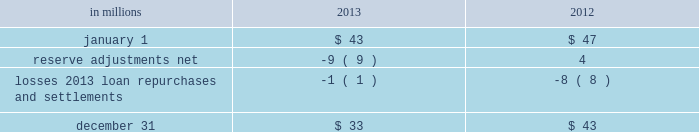Recourse and repurchase obligations as discussed in note 3 loan sale and servicing activities and variable interest entities , pnc has sold commercial mortgage , residential mortgage and home equity loans directly or indirectly through securitization and loan sale transactions in which we have continuing involvement .
One form of continuing involvement includes certain recourse and loan repurchase obligations associated with the transferred assets .
Commercial mortgage loan recourse obligations we originate , close and service certain multi-family commercial mortgage loans which are sold to fnma under fnma 2019s delegated underwriting and servicing ( dus ) program .
We participated in a similar program with the fhlmc .
Under these programs , we generally assume up to a one-third pari passu risk of loss on unpaid principal balances through a loss share arrangement .
At december 31 , 2013 and december 31 , 2012 , the unpaid principal balance outstanding of loans sold as a participant in these programs was $ 11.7 billion and $ 12.8 billion , respectively .
The potential maximum exposure under the loss share arrangements was $ 3.6 billion at december 31 , 2013 and $ 3.9 billion at december 31 , 2012 .
We maintain a reserve for estimated losses based upon our exposure .
The reserve for losses under these programs totaled $ 33 million and $ 43 million as of december 31 , 2013 and december 31 , 2012 , respectively , and is included in other liabilities on our consolidated balance sheet .
If payment is required under these programs , we would not have a contractual interest in the collateral underlying the mortgage loans on which losses occurred , although the value of the collateral is taken into account in determining our share of such losses .
Our exposure and activity associated with these recourse obligations are reported in the corporate & institutional banking segment .
Table 152 : analysis of commercial mortgage recourse obligations .
Residential mortgage loan and home equity repurchase obligations while residential mortgage loans are sold on a non-recourse basis , we assume certain loan repurchase obligations associated with mortgage loans we have sold to investors .
These loan repurchase obligations primarily relate to situations where pnc is alleged to have breached certain origination covenants and representations and warranties made to purchasers of the loans in the respective purchase and sale agreements .
For additional information on loan sales see note 3 loan sale and servicing activities and variable interest entities .
Our historical exposure and activity associated with agency securitization repurchase obligations has primarily been related to transactions with fnma and fhlmc , as indemnification and repurchase losses associated with fha and va-insured and uninsured loans pooled in gnma securitizations historically have been minimal .
Repurchase obligation activity associated with residential mortgages is reported in the residential mortgage banking segment .
In the fourth quarter of 2013 , pnc reached agreements with both fnma and fhlmc to resolve their repurchase claims with respect to loans sold between 2000 and 2008 .
Pnc paid a total of $ 191 million related to these settlements .
Pnc 2019s repurchase obligations also include certain brokered home equity loans/lines of credit that were sold to a limited number of private investors in the financial services industry by national city prior to our acquisition of national city .
Pnc is no longer engaged in the brokered home equity lending business , and our exposure under these loan repurchase obligations is limited to repurchases of loans sold in these transactions .
Repurchase activity associated with brokered home equity loans/lines of credit is reported in the non-strategic assets portfolio segment .
Indemnification and repurchase liabilities are initially recognized when loans are sold to investors and are subsequently evaluated by management .
Initial recognition and subsequent adjustments to the indemnification and repurchase liability for the sold residential mortgage portfolio are recognized in residential mortgage revenue on the consolidated income statement .
Since pnc is no longer engaged in the brokered home equity lending business , only subsequent adjustments are recognized to the home equity loans/lines indemnification and repurchase liability .
These adjustments are recognized in other noninterest income on the consolidated income statement .
214 the pnc financial services group , inc .
2013 form 10-k .
What was the average potential maximum exposure under the loss share arrangements in december 31 , 2013 and december 31 , 2012 in billions? 
Computations: ((3.6 + 3.9) / 2)
Answer: 3.75. 